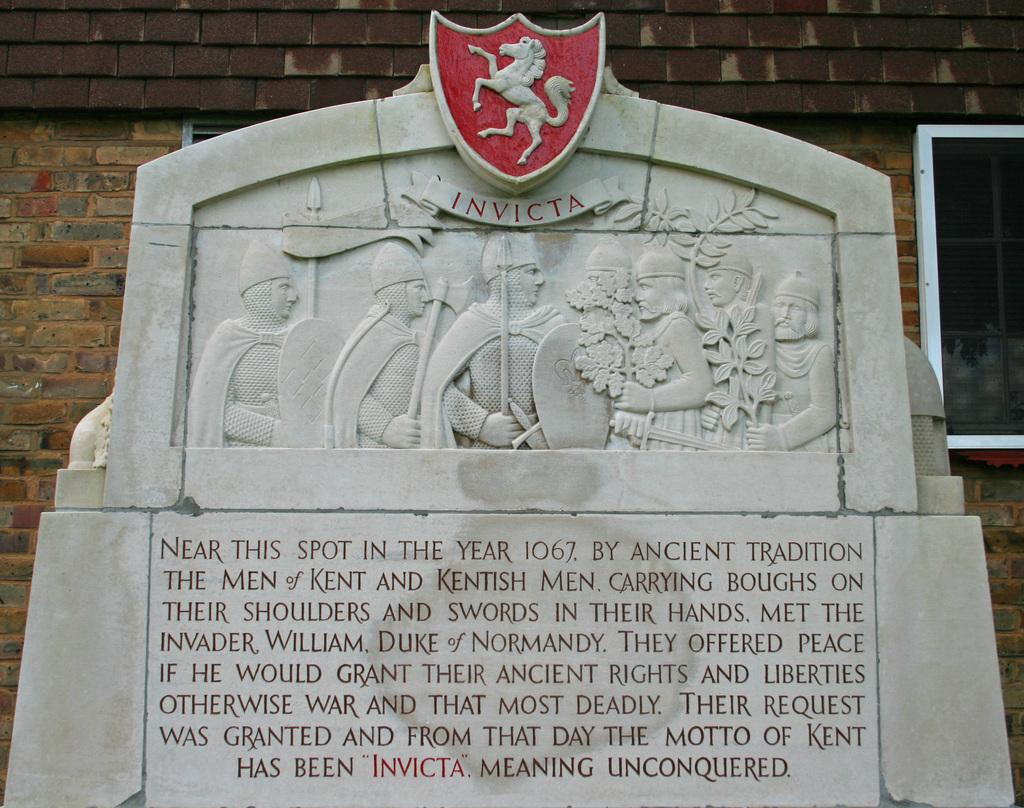What is the main subject of the image? The main subject of the image is sculptures on a gray color slab. What can be found on the gray color slab besides the sculptures? There are inscriptions on the gray color slab. What can be seen in the background of the image? There is a brick wall in the background. What type of plot does the son have in the image? There is no son or plot present in the image; it features sculptures on a gray color slab with inscriptions and a brick wall in the background. 